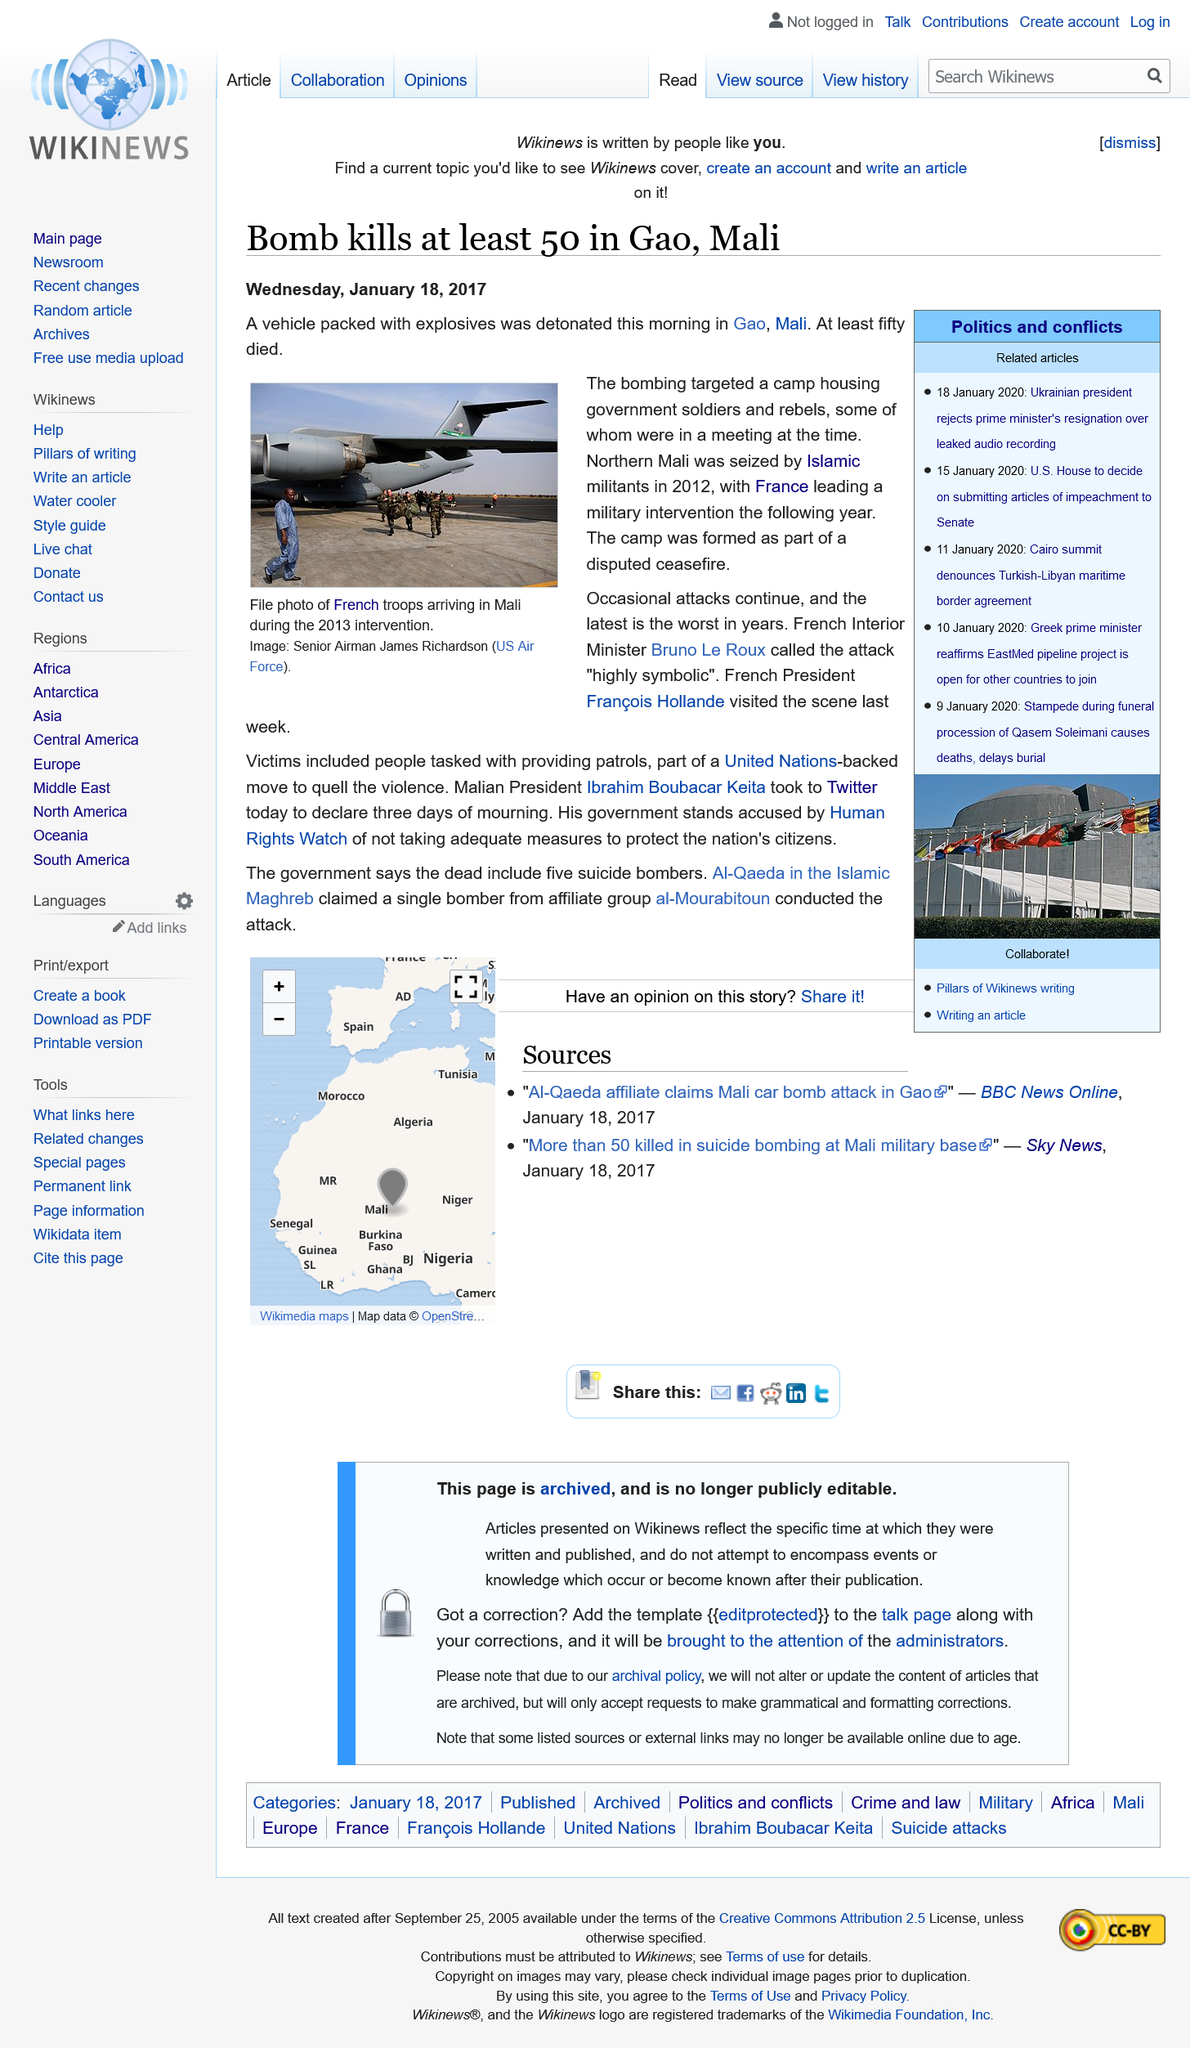Point out several critical features in this image. At least 50 people were killed in the attack. Five suicide bombers were killed in the attack. The French president visited the scene last week. 